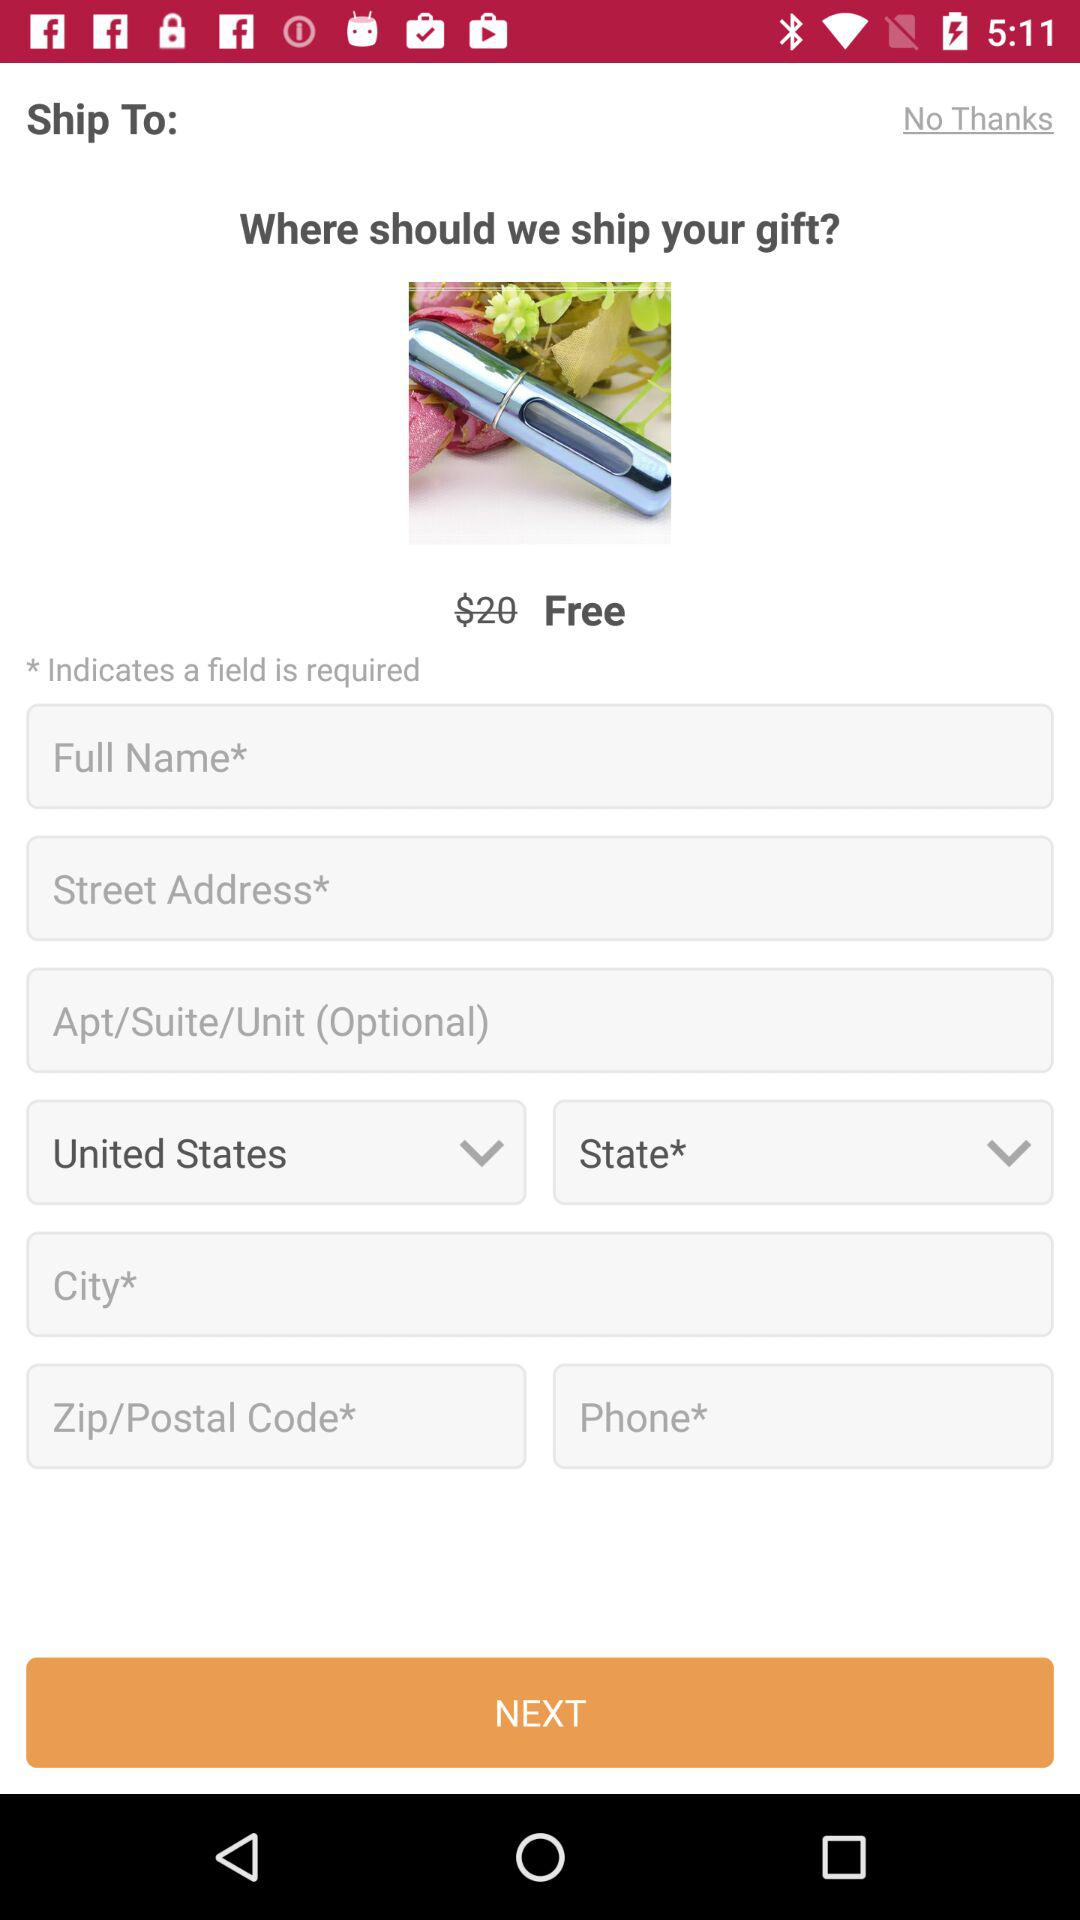How many text inputs are required to complete this form?
Answer the question using a single word or phrase. 6 